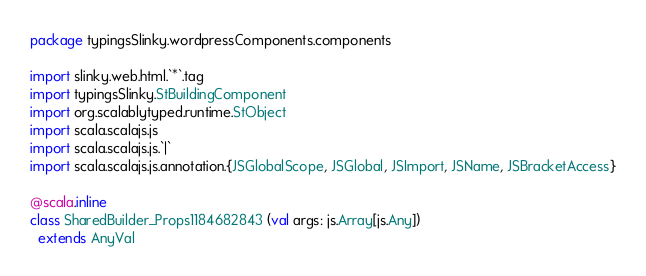Convert code to text. <code><loc_0><loc_0><loc_500><loc_500><_Scala_>package typingsSlinky.wordpressComponents.components

import slinky.web.html.`*`.tag
import typingsSlinky.StBuildingComponent
import org.scalablytyped.runtime.StObject
import scala.scalajs.js
import scala.scalajs.js.`|`
import scala.scalajs.js.annotation.{JSGlobalScope, JSGlobal, JSImport, JSName, JSBracketAccess}

@scala.inline
class SharedBuilder_Props1184682843 (val args: js.Array[js.Any])
  extends AnyVal</code> 